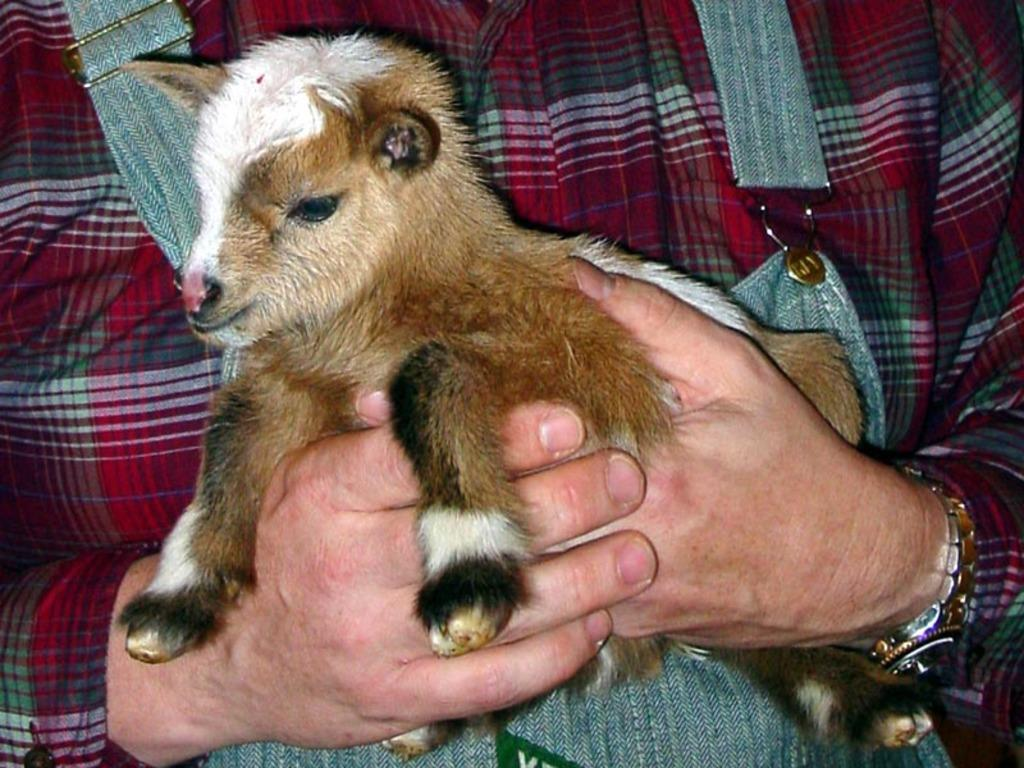Who is present in the image? There is a man in the image. What is the man wearing on his upper body? The man is wearing a red shirt and a denim coat. What is the man holding in his hands? The man is holding a small goat in his hands. What type of bread can be seen rising in the image? There is no bread present in the image; it features a man holding a small goat. 